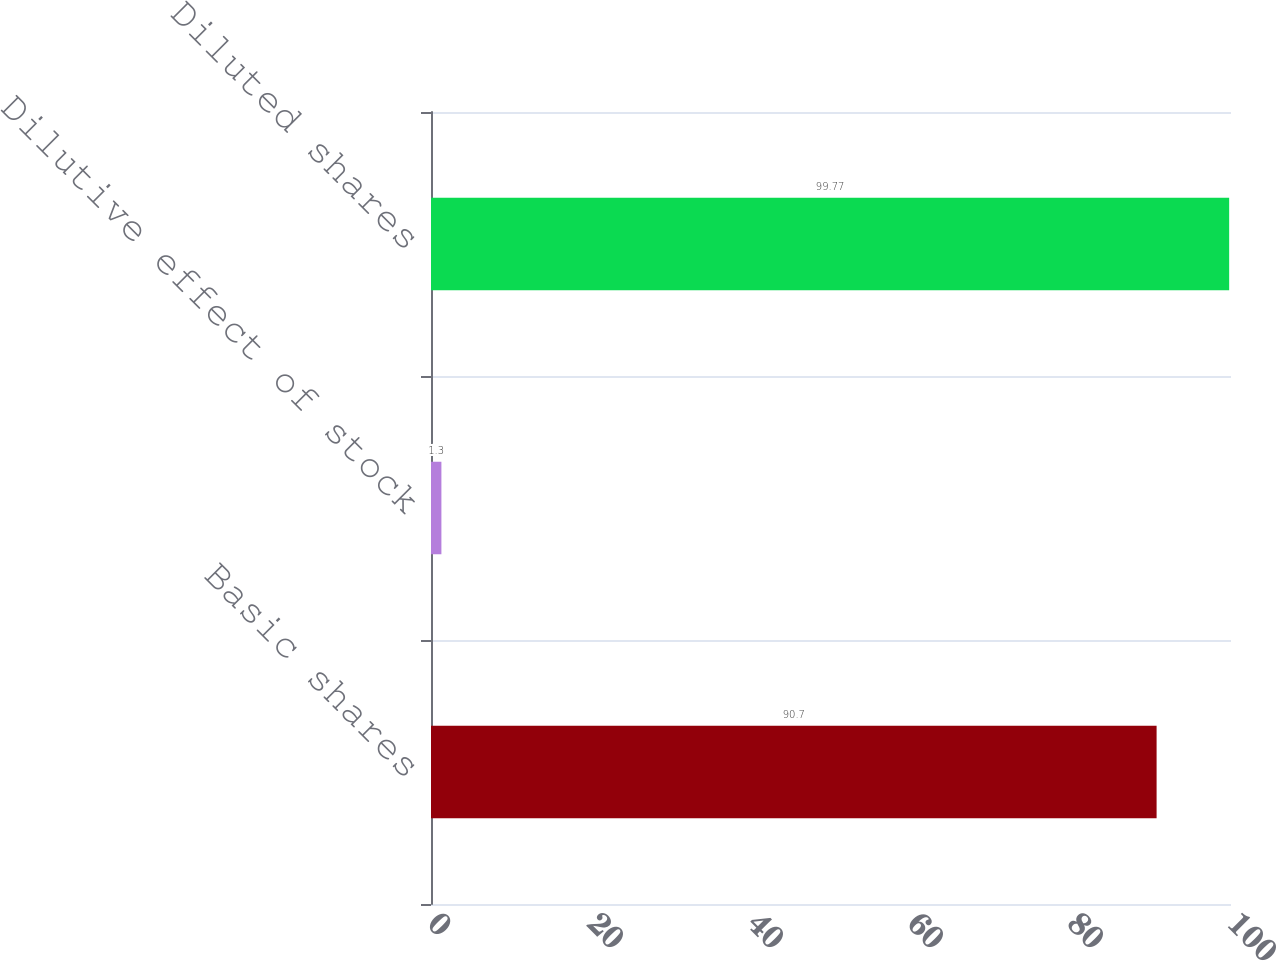Convert chart to OTSL. <chart><loc_0><loc_0><loc_500><loc_500><bar_chart><fcel>Basic shares<fcel>Dilutive effect of stock<fcel>Diluted shares<nl><fcel>90.7<fcel>1.3<fcel>99.77<nl></chart> 